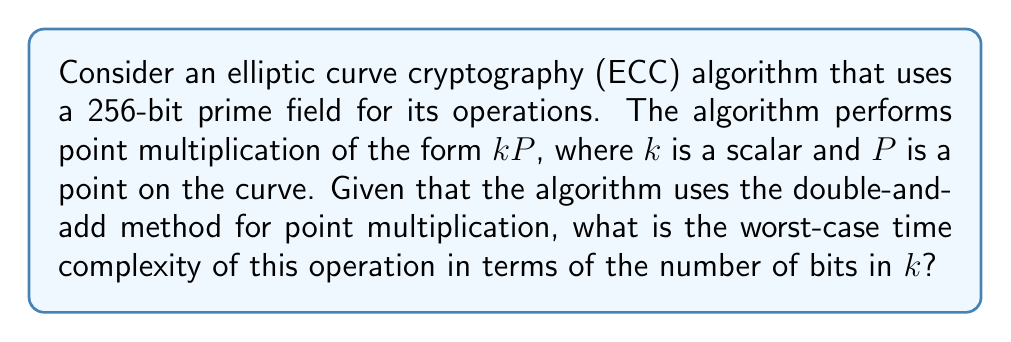Can you solve this math problem? To analyze the computational complexity of the ECC algorithm, we need to consider the following steps:

1. The double-and-add method is used for point multiplication in ECC.

2. For a scalar $k$ with $n$ bits, the algorithm performs the following operations:
   - Double operation: Always performed, once per bit.
   - Add operation: Performed only when the corresponding bit in $k$ is 1.

3. In the worst-case scenario, $k$ has all bits set to 1, which means:
   - Number of double operations = $n$
   - Number of add operations = $n$

4. Both doubling and adding operations on the elliptic curve have constant time complexity, let's denote it as $O(1)$.

5. The total number of operations in the worst case:
   $$(n \times O(1)) + (n \times O(1)) = 2n \times O(1)$$

6. Simplifying the expression:
   $$2n \times O(1) = O(n)$$

7. Therefore, the worst-case time complexity is linear in terms of the number of bits in $k$.

8. Since $k$ is in the same field as the curve (256-bit prime field), $n = 256$ in this case. However, the complexity is expressed in terms of $n$ for generalization.
Answer: $O(n)$, where $n$ is the number of bits in $k$ 